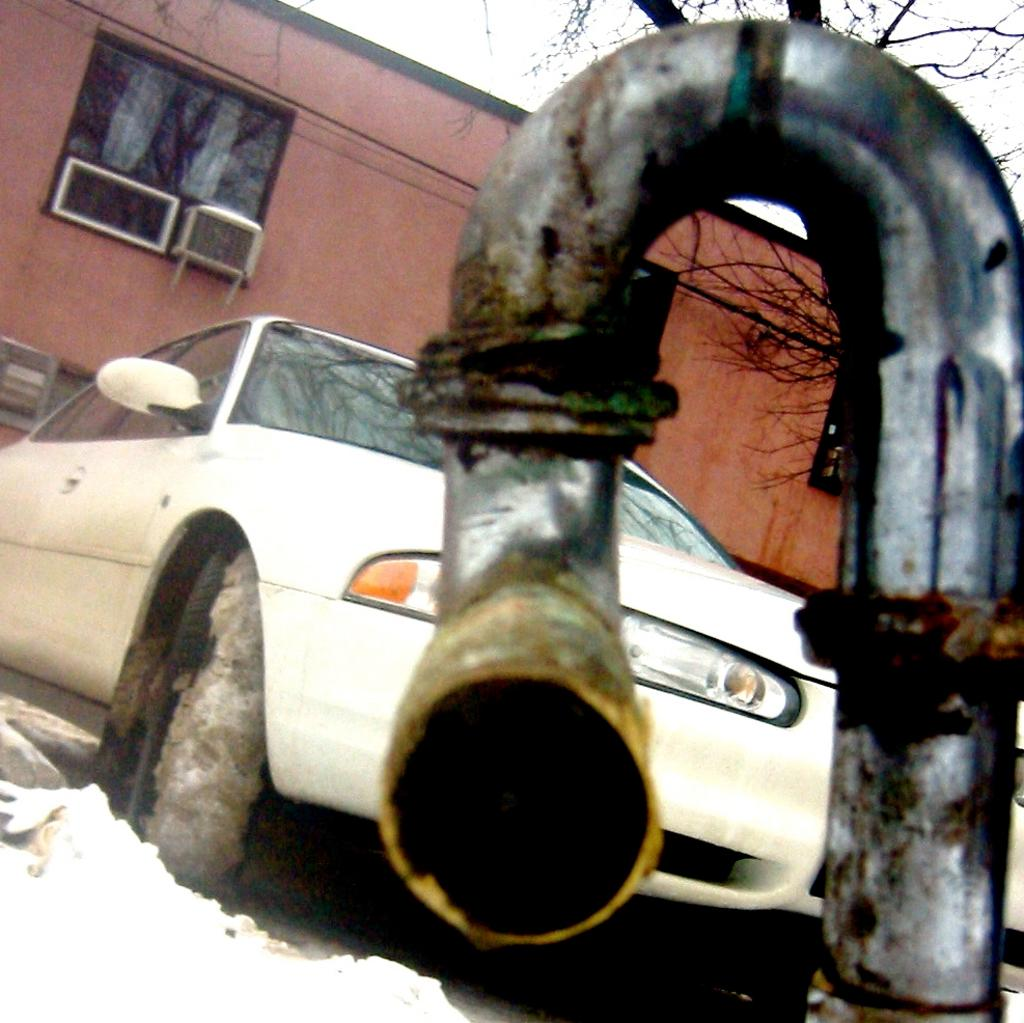What type of object can be seen in the image that is made of metal? There is a metal pipe in the image. What type of structure is visible in the image? There is a building with windows in the image. What device is installed on the building to regulate temperature? There is an air conditioner on the building. What type of vegetation can be seen in the image? There are trees visible in the image. What type of vehicle is parked in the image? There is a car parked in the image. Where is the sofa located in the image? There is no sofa present in the image. What type of attention is the air conditioner receiving in the image? The air conditioner is not receiving any specific attention in the image; it is simply installed on the building. 